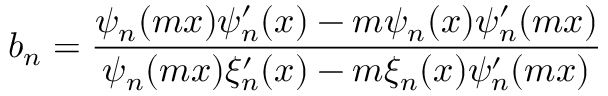Convert formula to latex. <formula><loc_0><loc_0><loc_500><loc_500>b _ { n } = \frac { \psi _ { n } ( m x ) \psi _ { n } ^ { \prime } ( x ) - m \psi _ { n } ( x ) \psi _ { n } ^ { \prime } ( m x ) } { \psi _ { n } ( m x ) \xi _ { n } ^ { \prime } ( x ) - m \xi _ { n } ( x ) \psi _ { n } ^ { \prime } ( m x ) }</formula> 